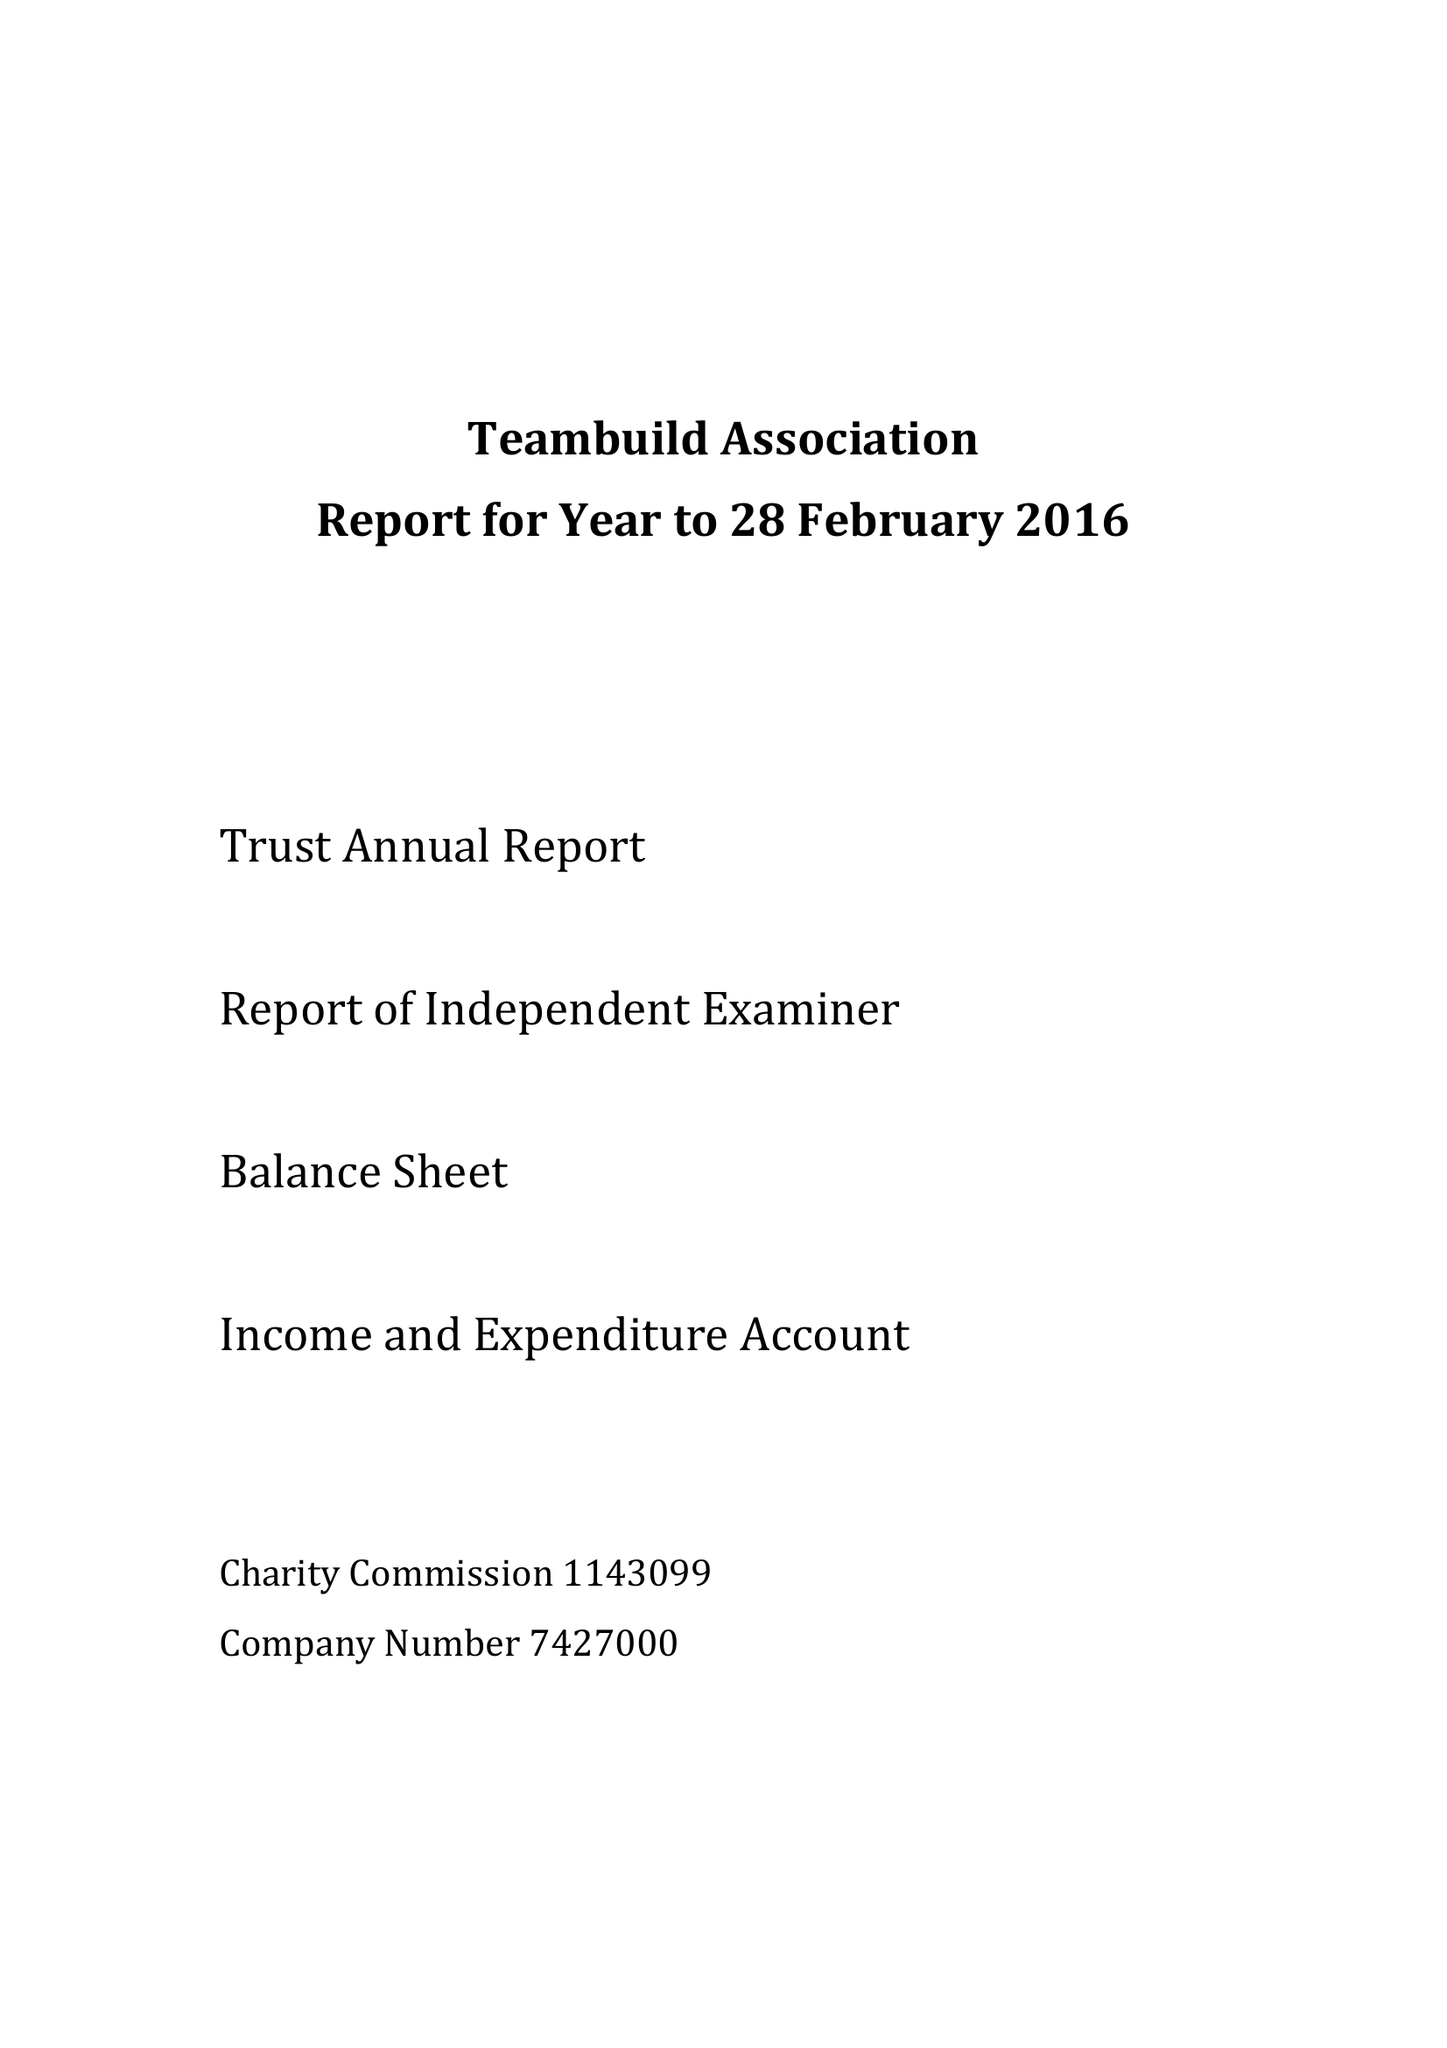What is the value for the report_date?
Answer the question using a single word or phrase. 2016-02-28 